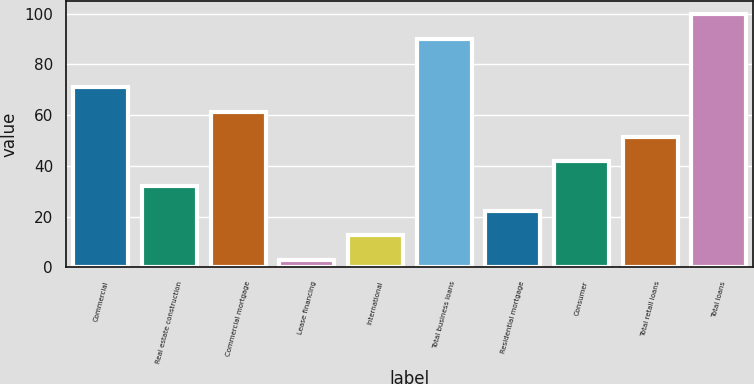Convert chart. <chart><loc_0><loc_0><loc_500><loc_500><bar_chart><fcel>Commercial<fcel>Real estate construction<fcel>Commercial mortgage<fcel>Lease financing<fcel>International<fcel>Total business loans<fcel>Residential mortgage<fcel>Consumer<fcel>Total retail loans<fcel>Total loans<nl><fcel>70.9<fcel>32.1<fcel>61.2<fcel>3<fcel>12.7<fcel>90<fcel>22.4<fcel>41.8<fcel>51.5<fcel>100<nl></chart> 